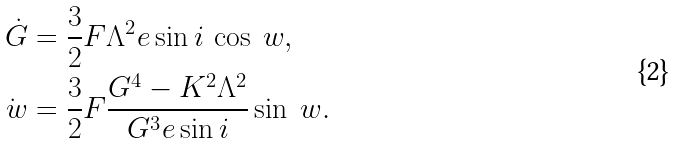Convert formula to latex. <formula><loc_0><loc_0><loc_500><loc_500>\dot { G } & = \frac { 3 } { 2 } F \Lambda ^ { 2 } e \sin i \, \cos \ w , \\ \dot { \ w } & = \frac { 3 } { 2 } F \frac { G ^ { 4 } - K ^ { 2 } \Lambda ^ { 2 } } { G ^ { 3 } e \sin i } \sin \ w .</formula> 